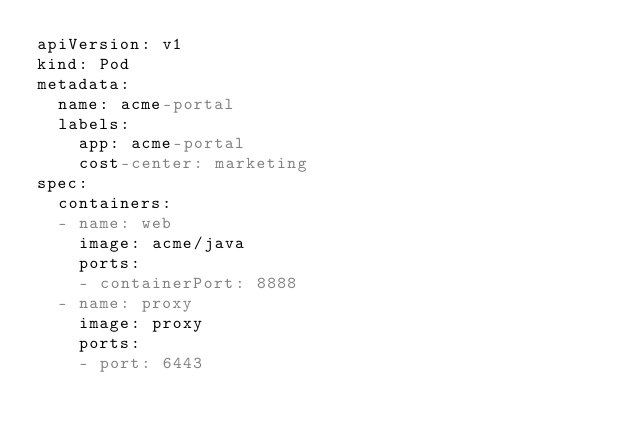<code> <loc_0><loc_0><loc_500><loc_500><_YAML_>apiVersion: v1
kind: Pod
metadata:
  name: acme-portal
  labels:
    app: acme-portal
    cost-center: marketing
spec:
  containers:
  - name: web
    image: acme/java
    ports:
    - containerPort: 8888
  - name: proxy
    image: proxy
    ports:
    - port: 6443
</code> 